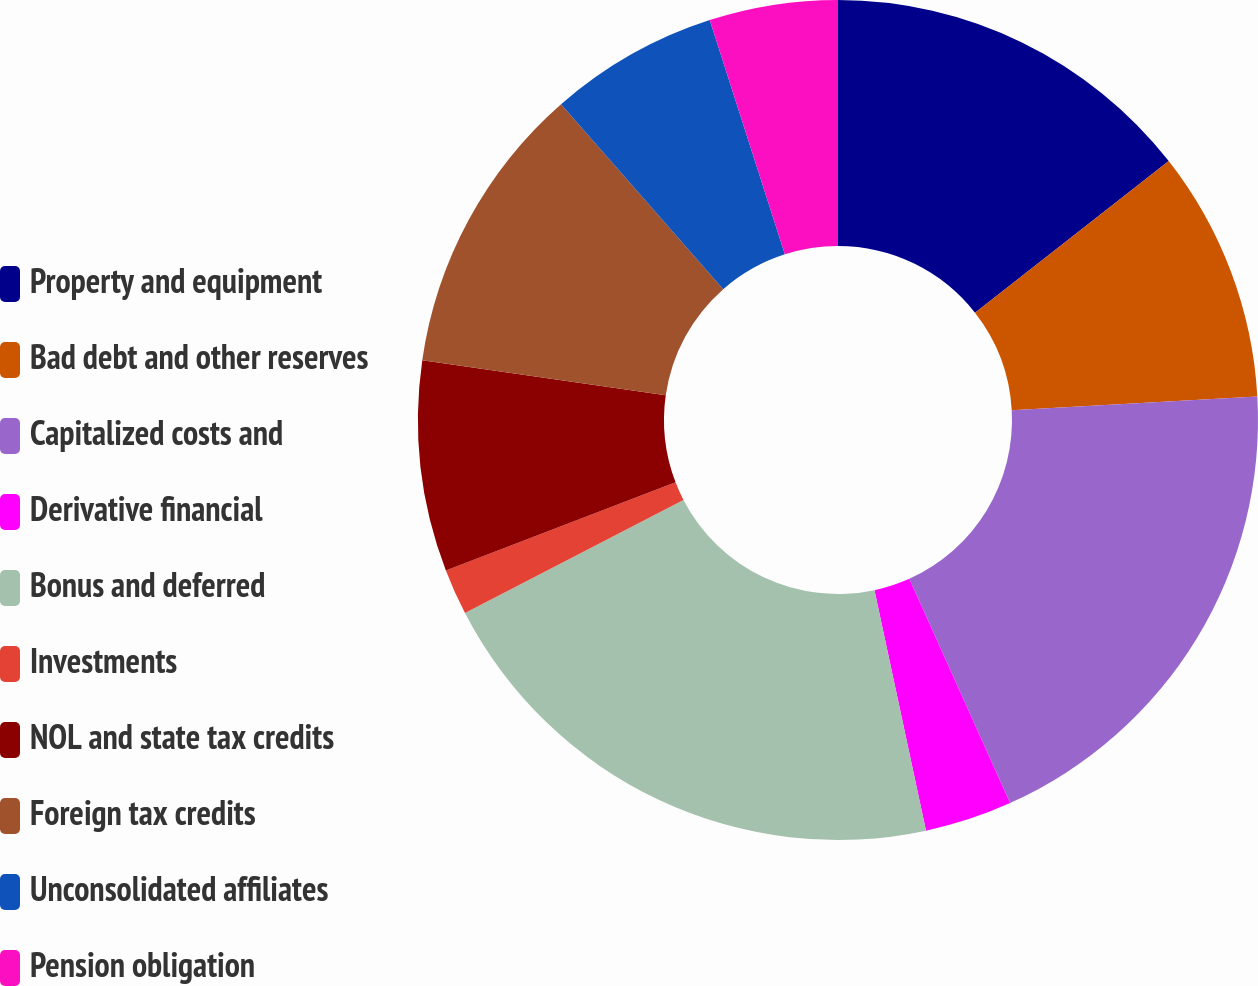Convert chart. <chart><loc_0><loc_0><loc_500><loc_500><pie_chart><fcel>Property and equipment<fcel>Bad debt and other reserves<fcel>Capitalized costs and<fcel>Derivative financial<fcel>Bonus and deferred<fcel>Investments<fcel>NOL and state tax credits<fcel>Foreign tax credits<fcel>Unconsolidated affiliates<fcel>Pension obligation<nl><fcel>14.43%<fcel>9.68%<fcel>19.17%<fcel>3.36%<fcel>20.76%<fcel>1.77%<fcel>8.1%<fcel>11.27%<fcel>6.52%<fcel>4.94%<nl></chart> 